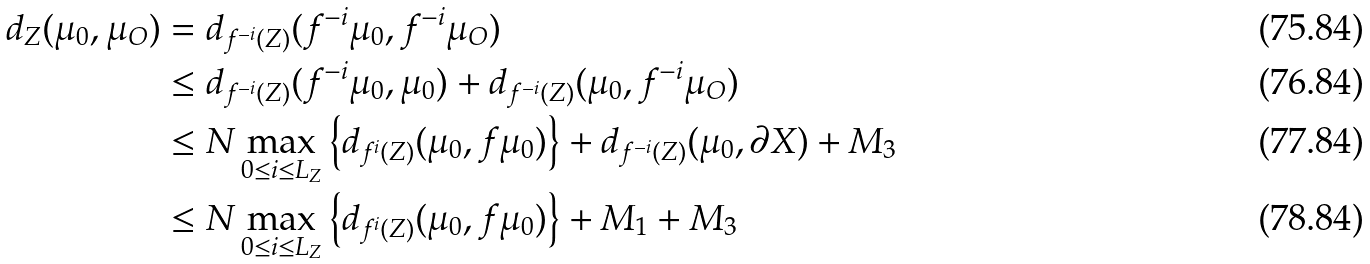<formula> <loc_0><loc_0><loc_500><loc_500>d _ { Z } ( \mu _ { 0 } , \mu _ { O } ) & = d _ { f ^ { - i } ( Z ) } ( f ^ { - i } \mu _ { 0 } , f ^ { - i } \mu _ { O } ) \\ & \leq d _ { f ^ { - i } ( Z ) } ( f ^ { - i } \mu _ { 0 } , \mu _ { 0 } ) + d _ { f ^ { - i } ( Z ) } ( \mu _ { 0 } , f ^ { - i } \mu _ { O } ) \\ & \leq N \max _ { 0 \leq i \leq L _ { Z } } \left \{ d _ { f ^ { i } ( Z ) } ( \mu _ { 0 } , f \mu _ { 0 } ) \right \} + d _ { f ^ { - i } ( Z ) } ( \mu _ { 0 } , \partial X ) + M _ { 3 } \\ & \leq N \max _ { 0 \leq i \leq L _ { Z } } \left \{ d _ { f ^ { i } ( Z ) } ( \mu _ { 0 } , f \mu _ { 0 } ) \right \} + M _ { 1 } + M _ { 3 }</formula> 